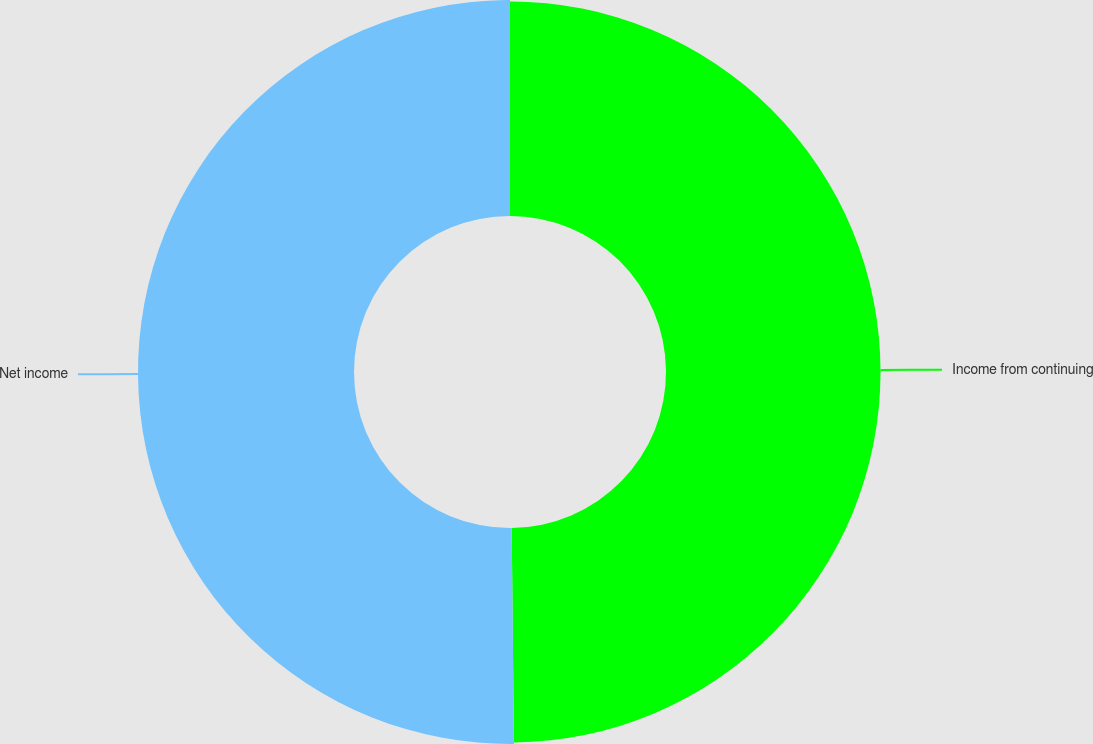<chart> <loc_0><loc_0><loc_500><loc_500><pie_chart><fcel>Income from continuing<fcel>Net income<nl><fcel>49.83%<fcel>50.17%<nl></chart> 